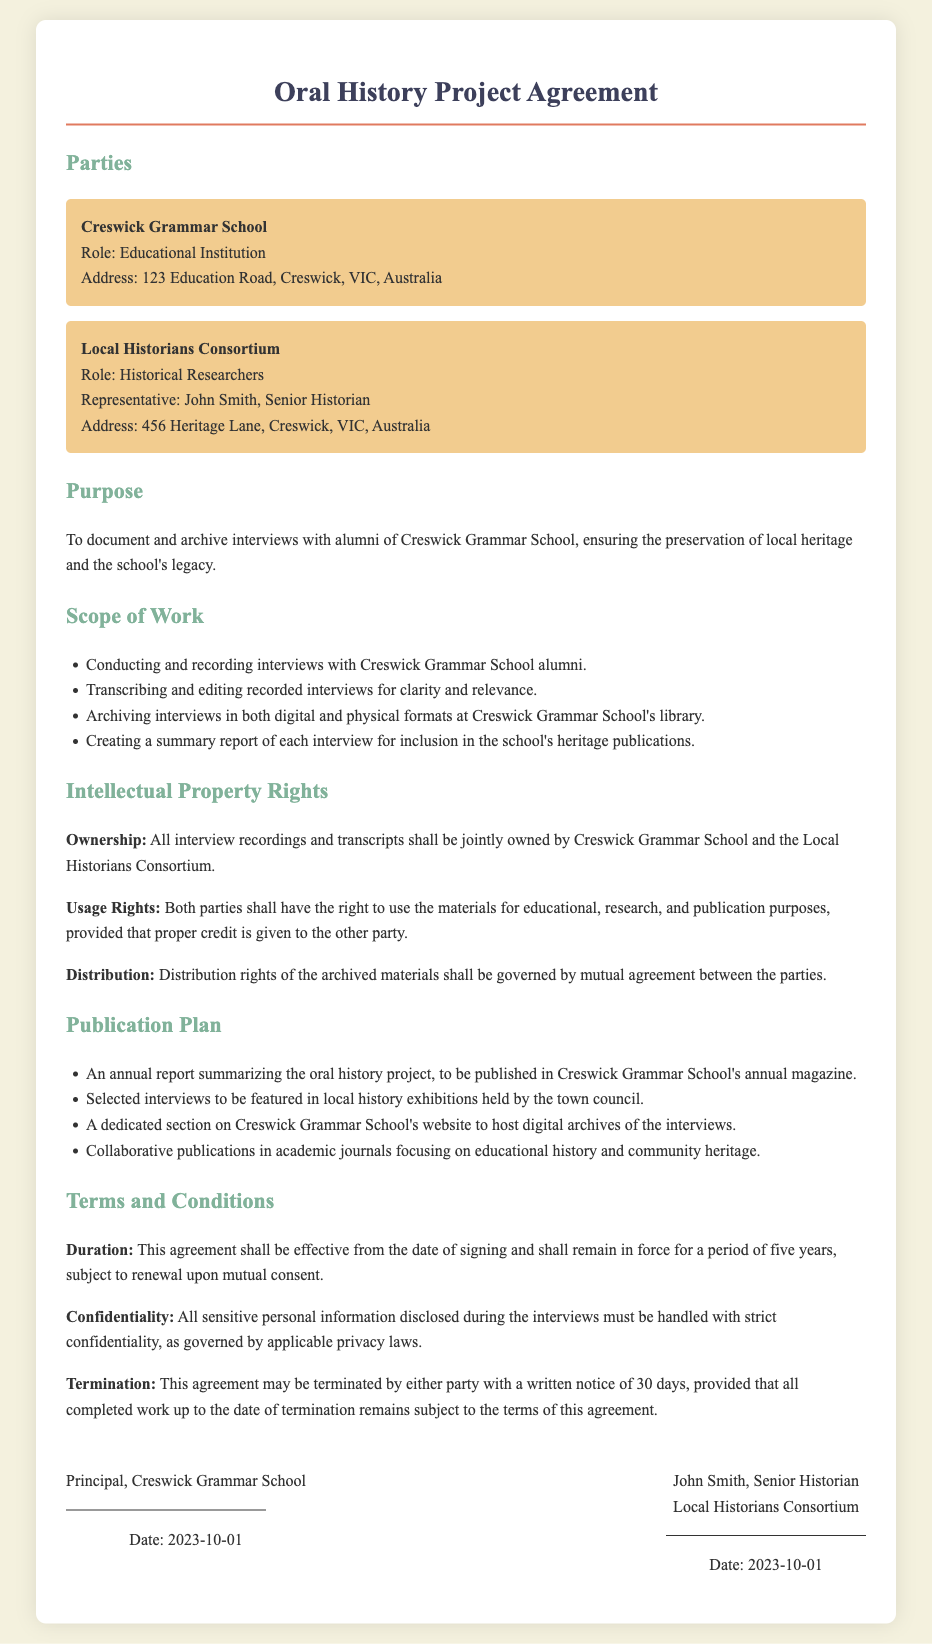What is the purpose of the agreement? The purpose of the agreement is to document and archive interviews with alumni of Creswick Grammar School, ensuring the preservation of local heritage and the school's legacy.
Answer: To document and archive interviews with alumni Who represents the Local Historians Consortium? John Smith is named as the representative for the Local Historians Consortium in the document.
Answer: John Smith How long will the agreement remain in force? The duration of the agreement is specified to be five years unless renewed by mutual consent.
Answer: Five years What is one of the scopes of work listed? The document lists several scopes of work, one of which is conducting and recording interviews with Creswick Grammar School alumni.
Answer: Conducting and recording interviews What rights do both parties have regarding the materials? The agreement states that both parties have the right to use the materials for educational, research, and publication purposes, provided that proper credit is given to the other party.
Answer: Use for educational, research, and publication purposes What is one planned publication mentioned in the document? The document outlines that there will be an annual report summarizing the oral history project to be published in Creswick Grammar School's annual magazine.
Answer: Annual report in the school's magazine Who will sign the agreement as the principal? The agreement states that the Principal of Creswick Grammar School will sign the document.
Answer: Principal, Creswick Grammar School 